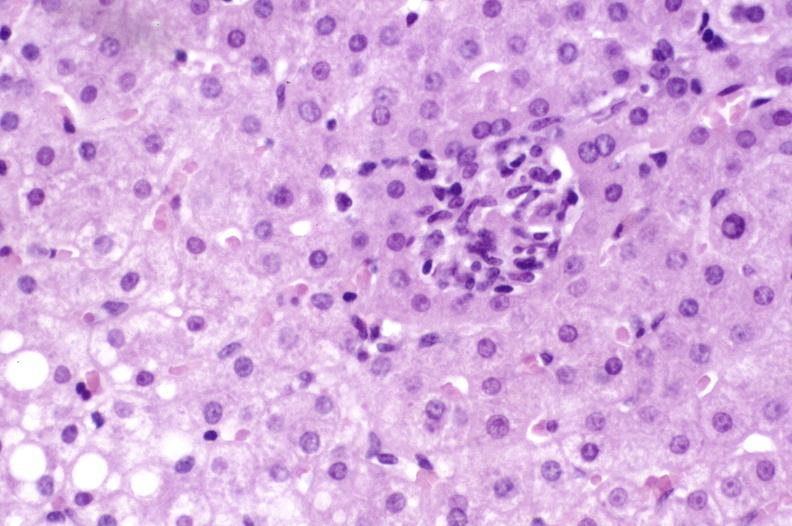s inflamed exocervix present?
Answer the question using a single word or phrase. No 